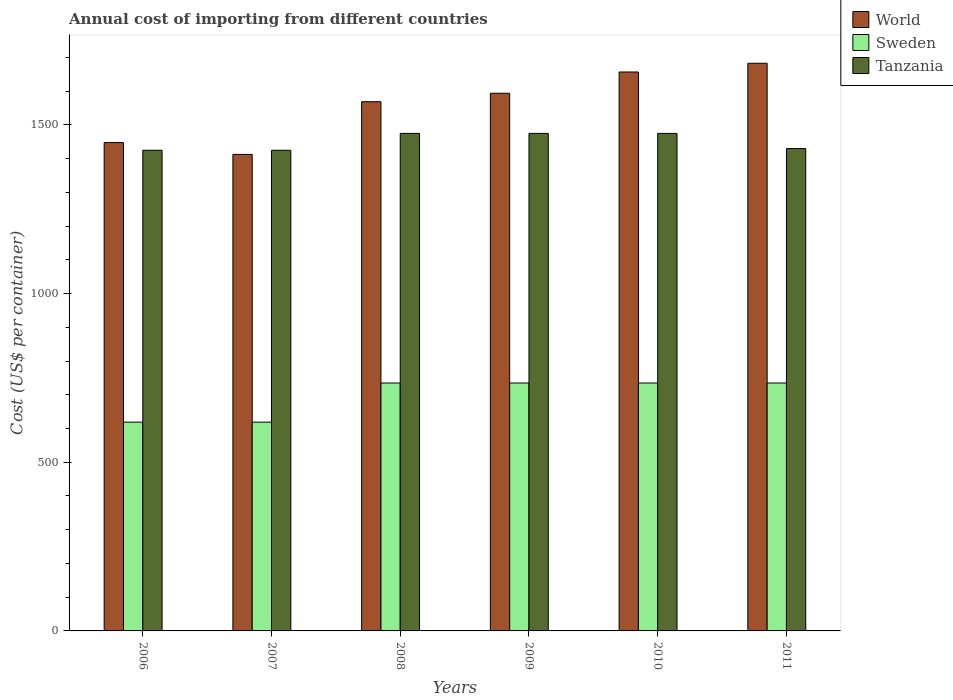How many different coloured bars are there?
Give a very brief answer. 3. Are the number of bars per tick equal to the number of legend labels?
Keep it short and to the point. Yes. How many bars are there on the 1st tick from the left?
Offer a very short reply. 3. What is the label of the 4th group of bars from the left?
Provide a succinct answer. 2009. What is the total annual cost of importing in World in 2008?
Your response must be concise. 1568.95. Across all years, what is the maximum total annual cost of importing in Tanzania?
Offer a terse response. 1475. Across all years, what is the minimum total annual cost of importing in Sweden?
Give a very brief answer. 619. In which year was the total annual cost of importing in World maximum?
Your response must be concise. 2011. In which year was the total annual cost of importing in World minimum?
Provide a succinct answer. 2007. What is the total total annual cost of importing in World in the graph?
Offer a very short reply. 9363.22. What is the difference between the total annual cost of importing in Tanzania in 2008 and that in 2009?
Give a very brief answer. 0. What is the difference between the total annual cost of importing in Tanzania in 2010 and the total annual cost of importing in Sweden in 2009?
Provide a succinct answer. 740. What is the average total annual cost of importing in Tanzania per year?
Offer a terse response. 1450.83. In the year 2008, what is the difference between the total annual cost of importing in Sweden and total annual cost of importing in World?
Your answer should be very brief. -833.95. What is the ratio of the total annual cost of importing in World in 2006 to that in 2011?
Provide a succinct answer. 0.86. Is the total annual cost of importing in Sweden in 2009 less than that in 2011?
Keep it short and to the point. No. What is the difference between the highest and the second highest total annual cost of importing in World?
Offer a terse response. 25.89. What is the difference between the highest and the lowest total annual cost of importing in World?
Provide a short and direct response. 270.31. Is the sum of the total annual cost of importing in Sweden in 2006 and 2010 greater than the maximum total annual cost of importing in Tanzania across all years?
Your answer should be very brief. No. What does the 3rd bar from the right in 2011 represents?
Your response must be concise. World. Is it the case that in every year, the sum of the total annual cost of importing in Sweden and total annual cost of importing in Tanzania is greater than the total annual cost of importing in World?
Make the answer very short. Yes. Are the values on the major ticks of Y-axis written in scientific E-notation?
Provide a short and direct response. No. How many legend labels are there?
Make the answer very short. 3. What is the title of the graph?
Your answer should be very brief. Annual cost of importing from different countries. What is the label or title of the Y-axis?
Your response must be concise. Cost (US$ per container). What is the Cost (US$ per container) of World in 2006?
Provide a succinct answer. 1447.74. What is the Cost (US$ per container) of Sweden in 2006?
Your response must be concise. 619. What is the Cost (US$ per container) of Tanzania in 2006?
Your answer should be very brief. 1425. What is the Cost (US$ per container) in World in 2007?
Offer a terse response. 1412.62. What is the Cost (US$ per container) of Sweden in 2007?
Provide a short and direct response. 619. What is the Cost (US$ per container) of Tanzania in 2007?
Give a very brief answer. 1425. What is the Cost (US$ per container) of World in 2008?
Offer a terse response. 1568.95. What is the Cost (US$ per container) in Sweden in 2008?
Your response must be concise. 735. What is the Cost (US$ per container) in Tanzania in 2008?
Provide a succinct answer. 1475. What is the Cost (US$ per container) in World in 2009?
Offer a terse response. 1593.96. What is the Cost (US$ per container) in Sweden in 2009?
Give a very brief answer. 735. What is the Cost (US$ per container) of Tanzania in 2009?
Your answer should be very brief. 1475. What is the Cost (US$ per container) of World in 2010?
Provide a succinct answer. 1657.04. What is the Cost (US$ per container) of Sweden in 2010?
Make the answer very short. 735. What is the Cost (US$ per container) in Tanzania in 2010?
Ensure brevity in your answer.  1475. What is the Cost (US$ per container) of World in 2011?
Make the answer very short. 1682.92. What is the Cost (US$ per container) in Sweden in 2011?
Offer a very short reply. 735. What is the Cost (US$ per container) of Tanzania in 2011?
Offer a very short reply. 1430. Across all years, what is the maximum Cost (US$ per container) in World?
Provide a short and direct response. 1682.92. Across all years, what is the maximum Cost (US$ per container) of Sweden?
Give a very brief answer. 735. Across all years, what is the maximum Cost (US$ per container) in Tanzania?
Offer a terse response. 1475. Across all years, what is the minimum Cost (US$ per container) of World?
Provide a short and direct response. 1412.62. Across all years, what is the minimum Cost (US$ per container) of Sweden?
Keep it short and to the point. 619. Across all years, what is the minimum Cost (US$ per container) of Tanzania?
Give a very brief answer. 1425. What is the total Cost (US$ per container) in World in the graph?
Your response must be concise. 9363.22. What is the total Cost (US$ per container) in Sweden in the graph?
Offer a very short reply. 4178. What is the total Cost (US$ per container) of Tanzania in the graph?
Make the answer very short. 8705. What is the difference between the Cost (US$ per container) of World in 2006 and that in 2007?
Offer a terse response. 35.12. What is the difference between the Cost (US$ per container) of World in 2006 and that in 2008?
Keep it short and to the point. -121.2. What is the difference between the Cost (US$ per container) of Sweden in 2006 and that in 2008?
Your answer should be compact. -116. What is the difference between the Cost (US$ per container) of Tanzania in 2006 and that in 2008?
Make the answer very short. -50. What is the difference between the Cost (US$ per container) of World in 2006 and that in 2009?
Offer a very short reply. -146.21. What is the difference between the Cost (US$ per container) of Sweden in 2006 and that in 2009?
Offer a very short reply. -116. What is the difference between the Cost (US$ per container) of Tanzania in 2006 and that in 2009?
Provide a short and direct response. -50. What is the difference between the Cost (US$ per container) of World in 2006 and that in 2010?
Ensure brevity in your answer.  -209.3. What is the difference between the Cost (US$ per container) in Sweden in 2006 and that in 2010?
Provide a short and direct response. -116. What is the difference between the Cost (US$ per container) in Tanzania in 2006 and that in 2010?
Your answer should be very brief. -50. What is the difference between the Cost (US$ per container) of World in 2006 and that in 2011?
Ensure brevity in your answer.  -235.18. What is the difference between the Cost (US$ per container) in Sweden in 2006 and that in 2011?
Your response must be concise. -116. What is the difference between the Cost (US$ per container) in Tanzania in 2006 and that in 2011?
Give a very brief answer. -5. What is the difference between the Cost (US$ per container) in World in 2007 and that in 2008?
Provide a succinct answer. -156.33. What is the difference between the Cost (US$ per container) in Sweden in 2007 and that in 2008?
Keep it short and to the point. -116. What is the difference between the Cost (US$ per container) in World in 2007 and that in 2009?
Give a very brief answer. -181.34. What is the difference between the Cost (US$ per container) of Sweden in 2007 and that in 2009?
Your answer should be compact. -116. What is the difference between the Cost (US$ per container) of Tanzania in 2007 and that in 2009?
Provide a short and direct response. -50. What is the difference between the Cost (US$ per container) in World in 2007 and that in 2010?
Offer a very short reply. -244.42. What is the difference between the Cost (US$ per container) in Sweden in 2007 and that in 2010?
Make the answer very short. -116. What is the difference between the Cost (US$ per container) of World in 2007 and that in 2011?
Keep it short and to the point. -270.31. What is the difference between the Cost (US$ per container) of Sweden in 2007 and that in 2011?
Your answer should be compact. -116. What is the difference between the Cost (US$ per container) in Tanzania in 2007 and that in 2011?
Provide a short and direct response. -5. What is the difference between the Cost (US$ per container) in World in 2008 and that in 2009?
Offer a very short reply. -25.01. What is the difference between the Cost (US$ per container) of Tanzania in 2008 and that in 2009?
Give a very brief answer. 0. What is the difference between the Cost (US$ per container) of World in 2008 and that in 2010?
Your response must be concise. -88.09. What is the difference between the Cost (US$ per container) in Sweden in 2008 and that in 2010?
Your answer should be compact. 0. What is the difference between the Cost (US$ per container) in Tanzania in 2008 and that in 2010?
Make the answer very short. 0. What is the difference between the Cost (US$ per container) in World in 2008 and that in 2011?
Your answer should be compact. -113.98. What is the difference between the Cost (US$ per container) of Sweden in 2008 and that in 2011?
Ensure brevity in your answer.  0. What is the difference between the Cost (US$ per container) of Tanzania in 2008 and that in 2011?
Offer a very short reply. 45. What is the difference between the Cost (US$ per container) in World in 2009 and that in 2010?
Your answer should be compact. -63.08. What is the difference between the Cost (US$ per container) of Tanzania in 2009 and that in 2010?
Your response must be concise. 0. What is the difference between the Cost (US$ per container) of World in 2009 and that in 2011?
Offer a very short reply. -88.97. What is the difference between the Cost (US$ per container) of Sweden in 2009 and that in 2011?
Offer a very short reply. 0. What is the difference between the Cost (US$ per container) in World in 2010 and that in 2011?
Your answer should be compact. -25.89. What is the difference between the Cost (US$ per container) in Tanzania in 2010 and that in 2011?
Your response must be concise. 45. What is the difference between the Cost (US$ per container) in World in 2006 and the Cost (US$ per container) in Sweden in 2007?
Provide a succinct answer. 828.74. What is the difference between the Cost (US$ per container) of World in 2006 and the Cost (US$ per container) of Tanzania in 2007?
Ensure brevity in your answer.  22.74. What is the difference between the Cost (US$ per container) in Sweden in 2006 and the Cost (US$ per container) in Tanzania in 2007?
Keep it short and to the point. -806. What is the difference between the Cost (US$ per container) of World in 2006 and the Cost (US$ per container) of Sweden in 2008?
Offer a very short reply. 712.74. What is the difference between the Cost (US$ per container) of World in 2006 and the Cost (US$ per container) of Tanzania in 2008?
Your response must be concise. -27.26. What is the difference between the Cost (US$ per container) of Sweden in 2006 and the Cost (US$ per container) of Tanzania in 2008?
Give a very brief answer. -856. What is the difference between the Cost (US$ per container) in World in 2006 and the Cost (US$ per container) in Sweden in 2009?
Your answer should be very brief. 712.74. What is the difference between the Cost (US$ per container) of World in 2006 and the Cost (US$ per container) of Tanzania in 2009?
Your response must be concise. -27.26. What is the difference between the Cost (US$ per container) in Sweden in 2006 and the Cost (US$ per container) in Tanzania in 2009?
Offer a very short reply. -856. What is the difference between the Cost (US$ per container) of World in 2006 and the Cost (US$ per container) of Sweden in 2010?
Ensure brevity in your answer.  712.74. What is the difference between the Cost (US$ per container) of World in 2006 and the Cost (US$ per container) of Tanzania in 2010?
Give a very brief answer. -27.26. What is the difference between the Cost (US$ per container) in Sweden in 2006 and the Cost (US$ per container) in Tanzania in 2010?
Your answer should be very brief. -856. What is the difference between the Cost (US$ per container) of World in 2006 and the Cost (US$ per container) of Sweden in 2011?
Ensure brevity in your answer.  712.74. What is the difference between the Cost (US$ per container) of World in 2006 and the Cost (US$ per container) of Tanzania in 2011?
Make the answer very short. 17.74. What is the difference between the Cost (US$ per container) of Sweden in 2006 and the Cost (US$ per container) of Tanzania in 2011?
Your answer should be compact. -811. What is the difference between the Cost (US$ per container) in World in 2007 and the Cost (US$ per container) in Sweden in 2008?
Give a very brief answer. 677.62. What is the difference between the Cost (US$ per container) in World in 2007 and the Cost (US$ per container) in Tanzania in 2008?
Provide a succinct answer. -62.38. What is the difference between the Cost (US$ per container) of Sweden in 2007 and the Cost (US$ per container) of Tanzania in 2008?
Your answer should be very brief. -856. What is the difference between the Cost (US$ per container) in World in 2007 and the Cost (US$ per container) in Sweden in 2009?
Provide a succinct answer. 677.62. What is the difference between the Cost (US$ per container) of World in 2007 and the Cost (US$ per container) of Tanzania in 2009?
Give a very brief answer. -62.38. What is the difference between the Cost (US$ per container) in Sweden in 2007 and the Cost (US$ per container) in Tanzania in 2009?
Your answer should be very brief. -856. What is the difference between the Cost (US$ per container) in World in 2007 and the Cost (US$ per container) in Sweden in 2010?
Keep it short and to the point. 677.62. What is the difference between the Cost (US$ per container) in World in 2007 and the Cost (US$ per container) in Tanzania in 2010?
Ensure brevity in your answer.  -62.38. What is the difference between the Cost (US$ per container) in Sweden in 2007 and the Cost (US$ per container) in Tanzania in 2010?
Provide a short and direct response. -856. What is the difference between the Cost (US$ per container) in World in 2007 and the Cost (US$ per container) in Sweden in 2011?
Your answer should be compact. 677.62. What is the difference between the Cost (US$ per container) of World in 2007 and the Cost (US$ per container) of Tanzania in 2011?
Give a very brief answer. -17.38. What is the difference between the Cost (US$ per container) in Sweden in 2007 and the Cost (US$ per container) in Tanzania in 2011?
Offer a terse response. -811. What is the difference between the Cost (US$ per container) in World in 2008 and the Cost (US$ per container) in Sweden in 2009?
Provide a short and direct response. 833.95. What is the difference between the Cost (US$ per container) of World in 2008 and the Cost (US$ per container) of Tanzania in 2009?
Your response must be concise. 93.95. What is the difference between the Cost (US$ per container) of Sweden in 2008 and the Cost (US$ per container) of Tanzania in 2009?
Provide a succinct answer. -740. What is the difference between the Cost (US$ per container) of World in 2008 and the Cost (US$ per container) of Sweden in 2010?
Offer a terse response. 833.95. What is the difference between the Cost (US$ per container) of World in 2008 and the Cost (US$ per container) of Tanzania in 2010?
Your answer should be very brief. 93.95. What is the difference between the Cost (US$ per container) in Sweden in 2008 and the Cost (US$ per container) in Tanzania in 2010?
Keep it short and to the point. -740. What is the difference between the Cost (US$ per container) in World in 2008 and the Cost (US$ per container) in Sweden in 2011?
Your answer should be compact. 833.95. What is the difference between the Cost (US$ per container) in World in 2008 and the Cost (US$ per container) in Tanzania in 2011?
Make the answer very short. 138.95. What is the difference between the Cost (US$ per container) in Sweden in 2008 and the Cost (US$ per container) in Tanzania in 2011?
Provide a succinct answer. -695. What is the difference between the Cost (US$ per container) in World in 2009 and the Cost (US$ per container) in Sweden in 2010?
Your response must be concise. 858.96. What is the difference between the Cost (US$ per container) of World in 2009 and the Cost (US$ per container) of Tanzania in 2010?
Offer a very short reply. 118.96. What is the difference between the Cost (US$ per container) of Sweden in 2009 and the Cost (US$ per container) of Tanzania in 2010?
Your answer should be compact. -740. What is the difference between the Cost (US$ per container) of World in 2009 and the Cost (US$ per container) of Sweden in 2011?
Your response must be concise. 858.96. What is the difference between the Cost (US$ per container) of World in 2009 and the Cost (US$ per container) of Tanzania in 2011?
Keep it short and to the point. 163.96. What is the difference between the Cost (US$ per container) of Sweden in 2009 and the Cost (US$ per container) of Tanzania in 2011?
Your response must be concise. -695. What is the difference between the Cost (US$ per container) of World in 2010 and the Cost (US$ per container) of Sweden in 2011?
Keep it short and to the point. 922.04. What is the difference between the Cost (US$ per container) of World in 2010 and the Cost (US$ per container) of Tanzania in 2011?
Your answer should be very brief. 227.04. What is the difference between the Cost (US$ per container) of Sweden in 2010 and the Cost (US$ per container) of Tanzania in 2011?
Give a very brief answer. -695. What is the average Cost (US$ per container) of World per year?
Your answer should be very brief. 1560.54. What is the average Cost (US$ per container) in Sweden per year?
Make the answer very short. 696.33. What is the average Cost (US$ per container) in Tanzania per year?
Provide a short and direct response. 1450.83. In the year 2006, what is the difference between the Cost (US$ per container) of World and Cost (US$ per container) of Sweden?
Your response must be concise. 828.74. In the year 2006, what is the difference between the Cost (US$ per container) in World and Cost (US$ per container) in Tanzania?
Give a very brief answer. 22.74. In the year 2006, what is the difference between the Cost (US$ per container) in Sweden and Cost (US$ per container) in Tanzania?
Give a very brief answer. -806. In the year 2007, what is the difference between the Cost (US$ per container) in World and Cost (US$ per container) in Sweden?
Ensure brevity in your answer.  793.62. In the year 2007, what is the difference between the Cost (US$ per container) of World and Cost (US$ per container) of Tanzania?
Your response must be concise. -12.38. In the year 2007, what is the difference between the Cost (US$ per container) of Sweden and Cost (US$ per container) of Tanzania?
Offer a terse response. -806. In the year 2008, what is the difference between the Cost (US$ per container) in World and Cost (US$ per container) in Sweden?
Ensure brevity in your answer.  833.95. In the year 2008, what is the difference between the Cost (US$ per container) in World and Cost (US$ per container) in Tanzania?
Your response must be concise. 93.95. In the year 2008, what is the difference between the Cost (US$ per container) in Sweden and Cost (US$ per container) in Tanzania?
Your response must be concise. -740. In the year 2009, what is the difference between the Cost (US$ per container) in World and Cost (US$ per container) in Sweden?
Offer a terse response. 858.96. In the year 2009, what is the difference between the Cost (US$ per container) of World and Cost (US$ per container) of Tanzania?
Offer a very short reply. 118.96. In the year 2009, what is the difference between the Cost (US$ per container) in Sweden and Cost (US$ per container) in Tanzania?
Give a very brief answer. -740. In the year 2010, what is the difference between the Cost (US$ per container) of World and Cost (US$ per container) of Sweden?
Your answer should be very brief. 922.04. In the year 2010, what is the difference between the Cost (US$ per container) in World and Cost (US$ per container) in Tanzania?
Offer a very short reply. 182.04. In the year 2010, what is the difference between the Cost (US$ per container) in Sweden and Cost (US$ per container) in Tanzania?
Your answer should be compact. -740. In the year 2011, what is the difference between the Cost (US$ per container) in World and Cost (US$ per container) in Sweden?
Give a very brief answer. 947.92. In the year 2011, what is the difference between the Cost (US$ per container) in World and Cost (US$ per container) in Tanzania?
Provide a short and direct response. 252.92. In the year 2011, what is the difference between the Cost (US$ per container) of Sweden and Cost (US$ per container) of Tanzania?
Ensure brevity in your answer.  -695. What is the ratio of the Cost (US$ per container) of World in 2006 to that in 2007?
Give a very brief answer. 1.02. What is the ratio of the Cost (US$ per container) in Tanzania in 2006 to that in 2007?
Provide a short and direct response. 1. What is the ratio of the Cost (US$ per container) in World in 2006 to that in 2008?
Offer a very short reply. 0.92. What is the ratio of the Cost (US$ per container) in Sweden in 2006 to that in 2008?
Offer a very short reply. 0.84. What is the ratio of the Cost (US$ per container) of Tanzania in 2006 to that in 2008?
Your answer should be compact. 0.97. What is the ratio of the Cost (US$ per container) in World in 2006 to that in 2009?
Keep it short and to the point. 0.91. What is the ratio of the Cost (US$ per container) of Sweden in 2006 to that in 2009?
Provide a succinct answer. 0.84. What is the ratio of the Cost (US$ per container) of Tanzania in 2006 to that in 2009?
Your answer should be compact. 0.97. What is the ratio of the Cost (US$ per container) of World in 2006 to that in 2010?
Keep it short and to the point. 0.87. What is the ratio of the Cost (US$ per container) in Sweden in 2006 to that in 2010?
Give a very brief answer. 0.84. What is the ratio of the Cost (US$ per container) of Tanzania in 2006 to that in 2010?
Your answer should be very brief. 0.97. What is the ratio of the Cost (US$ per container) of World in 2006 to that in 2011?
Give a very brief answer. 0.86. What is the ratio of the Cost (US$ per container) in Sweden in 2006 to that in 2011?
Provide a succinct answer. 0.84. What is the ratio of the Cost (US$ per container) of Tanzania in 2006 to that in 2011?
Your response must be concise. 1. What is the ratio of the Cost (US$ per container) of World in 2007 to that in 2008?
Offer a terse response. 0.9. What is the ratio of the Cost (US$ per container) of Sweden in 2007 to that in 2008?
Provide a succinct answer. 0.84. What is the ratio of the Cost (US$ per container) of Tanzania in 2007 to that in 2008?
Ensure brevity in your answer.  0.97. What is the ratio of the Cost (US$ per container) in World in 2007 to that in 2009?
Your response must be concise. 0.89. What is the ratio of the Cost (US$ per container) in Sweden in 2007 to that in 2009?
Your response must be concise. 0.84. What is the ratio of the Cost (US$ per container) of Tanzania in 2007 to that in 2009?
Your answer should be compact. 0.97. What is the ratio of the Cost (US$ per container) in World in 2007 to that in 2010?
Give a very brief answer. 0.85. What is the ratio of the Cost (US$ per container) of Sweden in 2007 to that in 2010?
Make the answer very short. 0.84. What is the ratio of the Cost (US$ per container) in Tanzania in 2007 to that in 2010?
Ensure brevity in your answer.  0.97. What is the ratio of the Cost (US$ per container) of World in 2007 to that in 2011?
Keep it short and to the point. 0.84. What is the ratio of the Cost (US$ per container) of Sweden in 2007 to that in 2011?
Provide a succinct answer. 0.84. What is the ratio of the Cost (US$ per container) of World in 2008 to that in 2009?
Your answer should be very brief. 0.98. What is the ratio of the Cost (US$ per container) of Sweden in 2008 to that in 2009?
Make the answer very short. 1. What is the ratio of the Cost (US$ per container) in Tanzania in 2008 to that in 2009?
Offer a very short reply. 1. What is the ratio of the Cost (US$ per container) of World in 2008 to that in 2010?
Provide a short and direct response. 0.95. What is the ratio of the Cost (US$ per container) in Sweden in 2008 to that in 2010?
Your response must be concise. 1. What is the ratio of the Cost (US$ per container) of World in 2008 to that in 2011?
Offer a very short reply. 0.93. What is the ratio of the Cost (US$ per container) in Tanzania in 2008 to that in 2011?
Your answer should be very brief. 1.03. What is the ratio of the Cost (US$ per container) in World in 2009 to that in 2010?
Offer a very short reply. 0.96. What is the ratio of the Cost (US$ per container) of Tanzania in 2009 to that in 2010?
Give a very brief answer. 1. What is the ratio of the Cost (US$ per container) of World in 2009 to that in 2011?
Provide a short and direct response. 0.95. What is the ratio of the Cost (US$ per container) in Tanzania in 2009 to that in 2011?
Keep it short and to the point. 1.03. What is the ratio of the Cost (US$ per container) of World in 2010 to that in 2011?
Your response must be concise. 0.98. What is the ratio of the Cost (US$ per container) of Sweden in 2010 to that in 2011?
Offer a very short reply. 1. What is the ratio of the Cost (US$ per container) in Tanzania in 2010 to that in 2011?
Offer a terse response. 1.03. What is the difference between the highest and the second highest Cost (US$ per container) of World?
Give a very brief answer. 25.89. What is the difference between the highest and the lowest Cost (US$ per container) in World?
Provide a short and direct response. 270.31. What is the difference between the highest and the lowest Cost (US$ per container) of Sweden?
Offer a very short reply. 116. What is the difference between the highest and the lowest Cost (US$ per container) in Tanzania?
Offer a terse response. 50. 